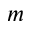<formula> <loc_0><loc_0><loc_500><loc_500>m</formula> 